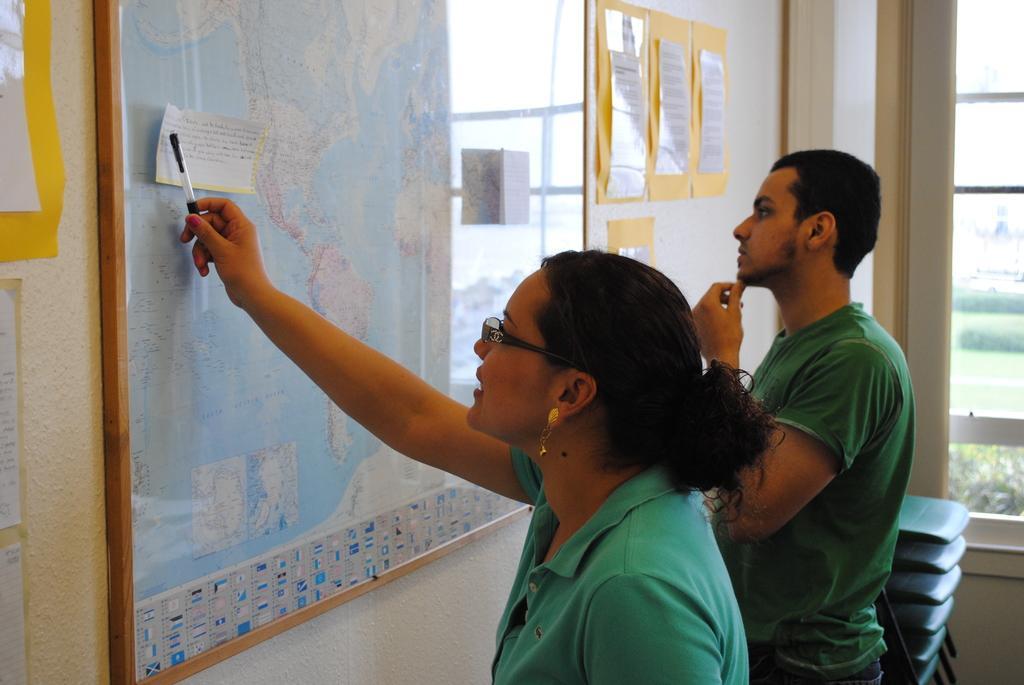Could you give a brief overview of what you see in this image? In this image we can see a man and a woman. In front of them, we can see a map and papers are attached to the wall. We can see a window and chairs on the right side of the image. 